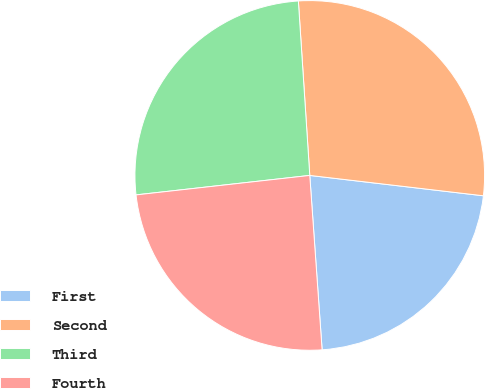Convert chart. <chart><loc_0><loc_0><loc_500><loc_500><pie_chart><fcel>First<fcel>Second<fcel>Third<fcel>Fourth<nl><fcel>22.02%<fcel>27.9%<fcel>25.74%<fcel>24.35%<nl></chart> 